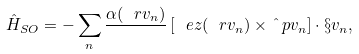Convert formula to latex. <formula><loc_0><loc_0><loc_500><loc_500>\hat { H } _ { S O } = - \sum _ { n } \frac { \alpha ( \ r v _ { n } ) } { } \left [ \ e z ( \ r v _ { n } ) \times \hat { \ } p v _ { n } \right ] \cdot \S v _ { n } ,</formula> 